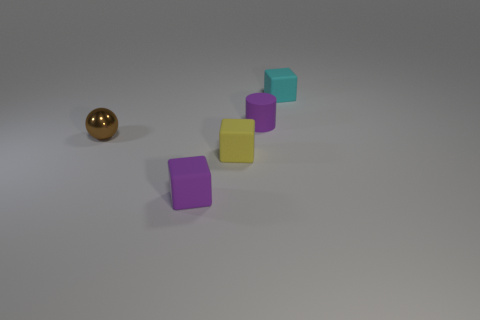Add 5 purple things. How many objects exist? 10 Subtract all blocks. How many objects are left? 2 Add 5 small purple cylinders. How many small purple cylinders are left? 6 Add 2 spheres. How many spheres exist? 3 Subtract 0 blue blocks. How many objects are left? 5 Subtract all cyan rubber blocks. Subtract all green metal cylinders. How many objects are left? 4 